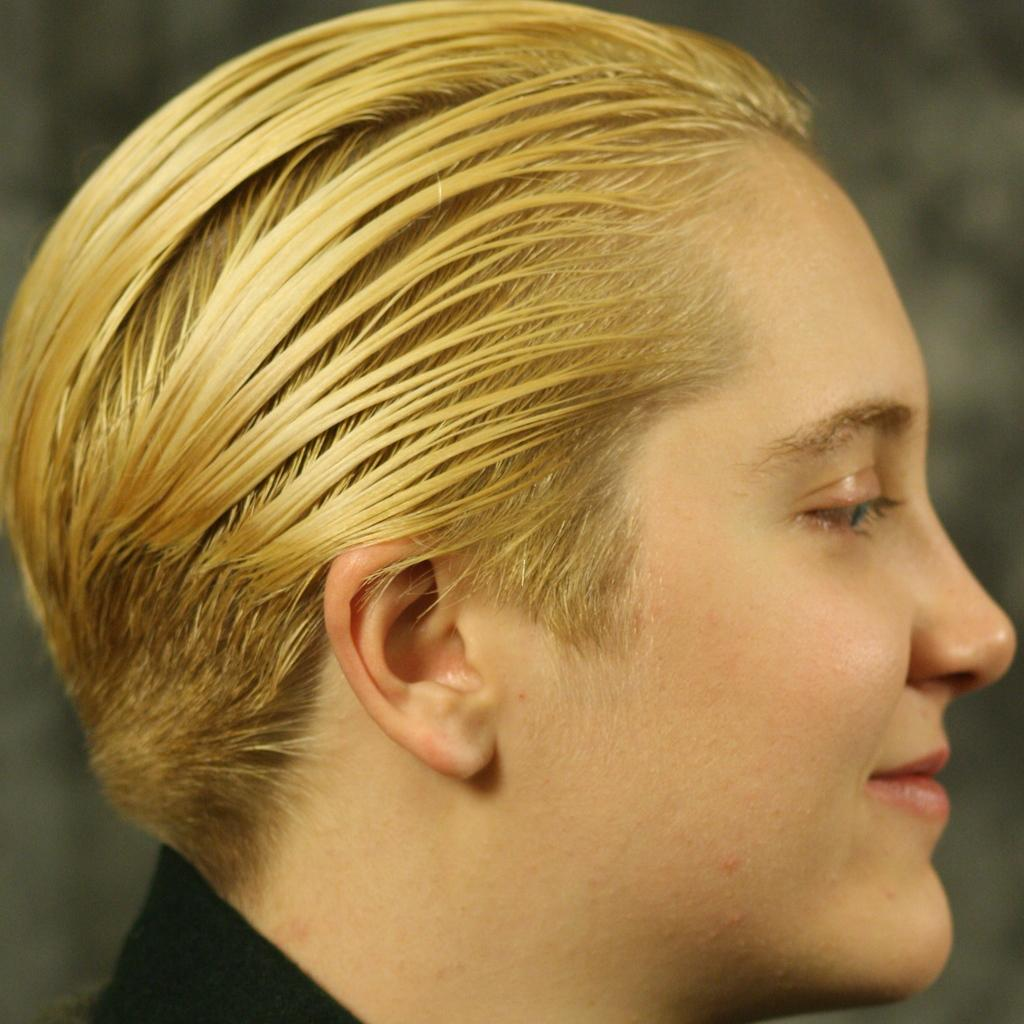What is the main subject of the image? The main subject of the image is a side view image of a person's face. Can you describe the background of the image? The background of the image is blurred. How far away is the mist in the image? There is no mist present in the image. What type of texture does the person's face have in the image? The provided facts do not mention the texture of the person's face in the image. 